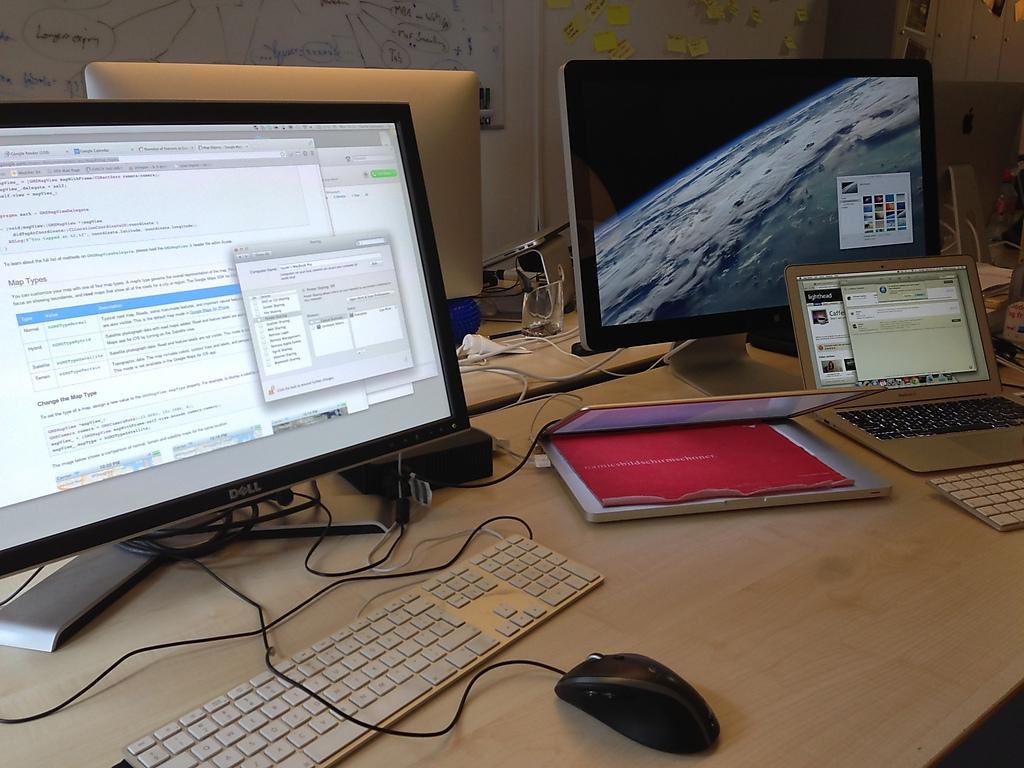<image>
Present a compact description of the photo's key features. Two laptops sit on a desk next to a Dell monitor and another monitor. 